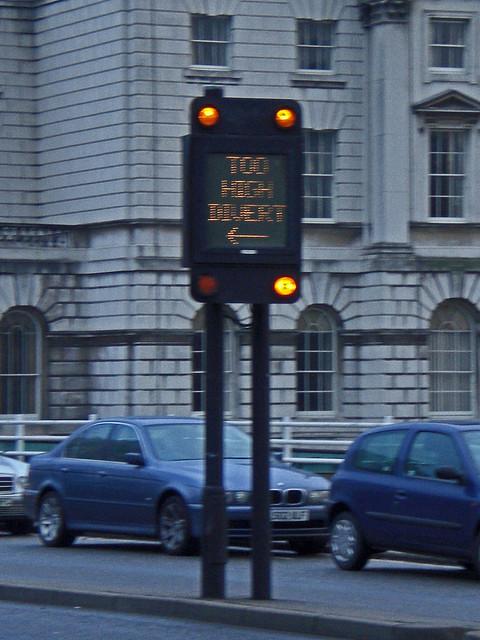What is the BMW's license plate?
Give a very brief answer. Can't tell. What does the sign say?
Short answer required. Too high divert. Was this picture taken in the U.S.?
Give a very brief answer. No. 